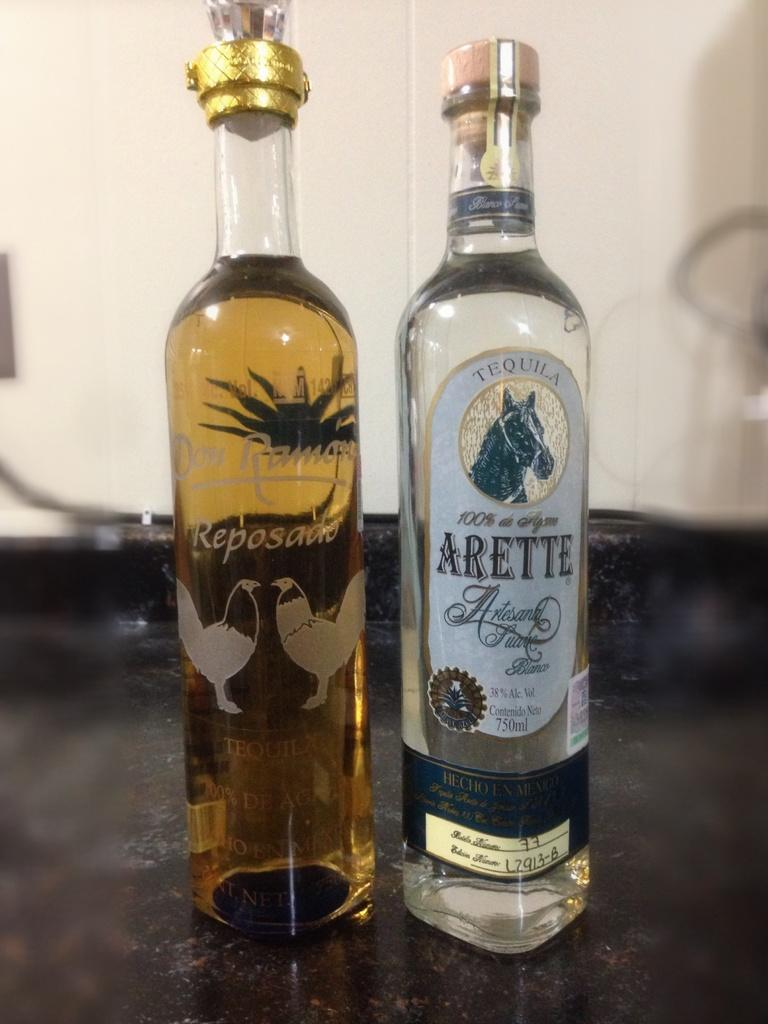<image>
Share a concise interpretation of the image provided. A bottle of Arette is sitting on a table next to a bottle of Don Ramon. 